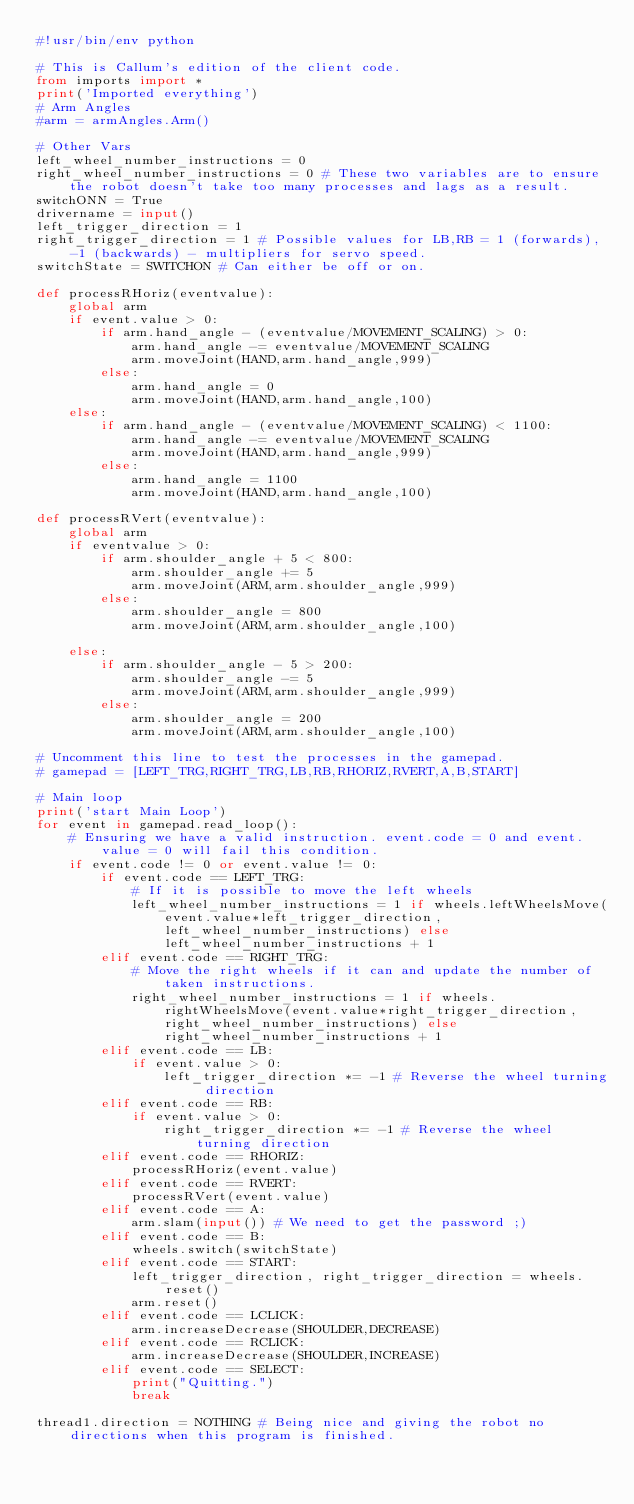Convert code to text. <code><loc_0><loc_0><loc_500><loc_500><_Python_>#!usr/bin/env python

# This is Callum's edition of the client code.
from imports import *
print('Imported everything')
# Arm Angles
#arm = armAngles.Arm()

# Other Vars
left_wheel_number_instructions = 0
right_wheel_number_instructions = 0 # These two variables are to ensure the robot doesn't take too many processes and lags as a result.
switchONN = True
drivername = input()
left_trigger_direction = 1
right_trigger_direction = 1 # Possible values for LB,RB = 1 (forwards), -1 (backwards) - multipliers for servo speed.
switchState = SWITCHON # Can either be off or on.

def processRHoriz(eventvalue):
    global arm
    if event.value > 0:
        if arm.hand_angle - (eventvalue/MOVEMENT_SCALING) > 0:
            arm.hand_angle -= eventvalue/MOVEMENT_SCALING 
            arm.moveJoint(HAND,arm.hand_angle,999)
        else:
            arm.hand_angle = 0
            arm.moveJoint(HAND,arm.hand_angle,100)
    else:
        if arm.hand_angle - (eventvalue/MOVEMENT_SCALING) < 1100:
            arm.hand_angle -= eventvalue/MOVEMENT_SCALING 
            arm.moveJoint(HAND,arm.hand_angle,999)
        else:
            arm.hand_angle = 1100
            arm.moveJoint(HAND,arm.hand_angle,100)

def processRVert(eventvalue):
    global arm
    if eventvalue > 0:
        if arm.shoulder_angle + 5 < 800:
            arm.shoulder_angle += 5
            arm.moveJoint(ARM,arm.shoulder_angle,999)
        else:
            arm.shoulder_angle = 800
            arm.moveJoint(ARM,arm.shoulder_angle,100)

    else:
        if arm.shoulder_angle - 5 > 200:
            arm.shoulder_angle -= 5
            arm.moveJoint(ARM,arm.shoulder_angle,999)
        else:
            arm.shoulder_angle = 200
            arm.moveJoint(ARM,arm.shoulder_angle,100)

# Uncomment this line to test the processes in the gamepad.
# gamepad = [LEFT_TRG,RIGHT_TRG,LB,RB,RHORIZ,RVERT,A,B,START]

# Main loop
print('start Main Loop')
for event in gamepad.read_loop():
    # Ensuring we have a valid instruction. event.code = 0 and event.value = 0 will fail this condition.
    if event.code != 0 or event.value != 0:
        if event.code == LEFT_TRG:
            # If it is possible to move the left wheels
            left_wheel_number_instructions = 1 if wheels.leftWheelsMove(event.value*left_trigger_direction,left_wheel_number_instructions) else left_wheel_number_instructions + 1
        elif event.code == RIGHT_TRG:
            # Move the right wheels if it can and update the number of taken instructions.
            right_wheel_number_instructions = 1 if wheels.rightWheelsMove(event.value*right_trigger_direction,right_wheel_number_instructions) else right_wheel_number_instructions + 1
        elif event.code == LB:
            if event.value > 0:
                left_trigger_direction *= -1 # Reverse the wheel turning direction
        elif event.code == RB:
            if event.value > 0:
                right_trigger_direction *= -1 # Reverse the wheel turning direction
        elif event.code == RHORIZ:
            processRHoriz(event.value)
        elif event.code == RVERT:
            processRVert(event.value)
        elif event.code == A:
            arm.slam(input()) # We need to get the password ;)
        elif event.code == B:
            wheels.switch(switchState) 
        elif event.code == START:
            left_trigger_direction, right_trigger_direction = wheels.reset()
            arm.reset()
        elif event.code == LCLICK:
            arm.increaseDecrease(SHOULDER,DECREASE)
        elif event.code == RCLICK:
            arm.increaseDecrease(SHOULDER,INCREASE)
        elif event.code == SELECT:
            print("Quitting.")
            break
    
thread1.direction = NOTHING # Being nice and giving the robot no directions when this program is finished.
</code> 